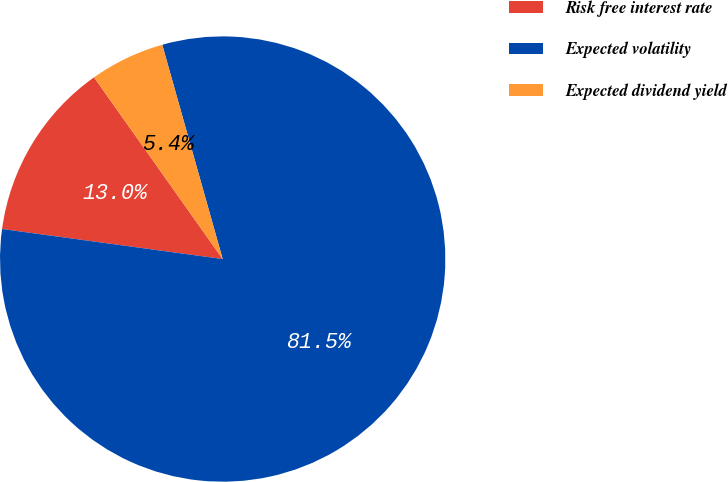Convert chart. <chart><loc_0><loc_0><loc_500><loc_500><pie_chart><fcel>Risk free interest rate<fcel>Expected volatility<fcel>Expected dividend yield<nl><fcel>13.04%<fcel>81.52%<fcel>5.43%<nl></chart> 